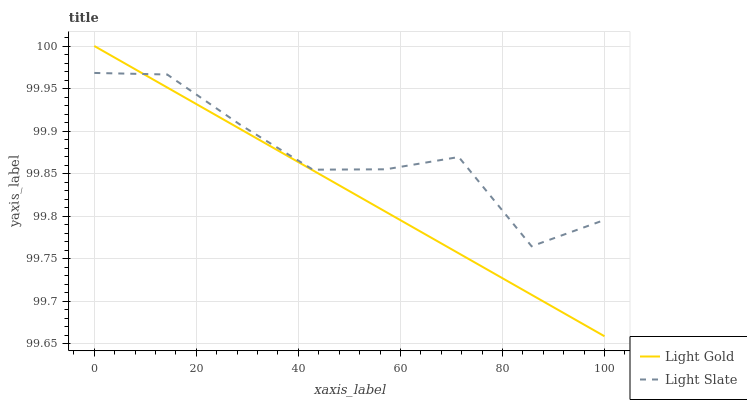Does Light Gold have the minimum area under the curve?
Answer yes or no. Yes. Does Light Slate have the maximum area under the curve?
Answer yes or no. Yes. Does Light Gold have the maximum area under the curve?
Answer yes or no. No. Is Light Gold the smoothest?
Answer yes or no. Yes. Is Light Slate the roughest?
Answer yes or no. Yes. Is Light Gold the roughest?
Answer yes or no. No. Does Light Gold have the lowest value?
Answer yes or no. Yes. Does Light Gold have the highest value?
Answer yes or no. Yes. Does Light Gold intersect Light Slate?
Answer yes or no. Yes. Is Light Gold less than Light Slate?
Answer yes or no. No. Is Light Gold greater than Light Slate?
Answer yes or no. No. 